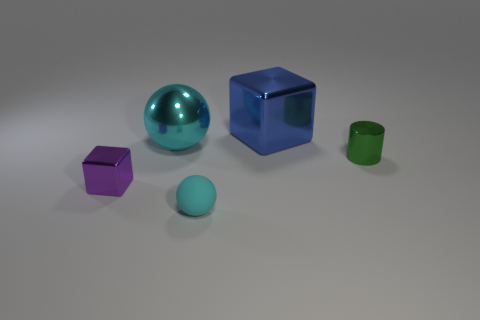Add 1 large red things. How many objects exist? 6 Subtract all blue cubes. How many cubes are left? 1 Subtract 1 spheres. How many spheres are left? 1 Subtract all gray cylinders. How many purple blocks are left? 1 Subtract all blue shiny cubes. Subtract all small blue metal cylinders. How many objects are left? 4 Add 2 small cylinders. How many small cylinders are left? 3 Add 5 small cyan matte objects. How many small cyan matte objects exist? 6 Subtract 0 blue balls. How many objects are left? 5 Subtract all balls. How many objects are left? 3 Subtract all gray cylinders. Subtract all blue blocks. How many cylinders are left? 1 